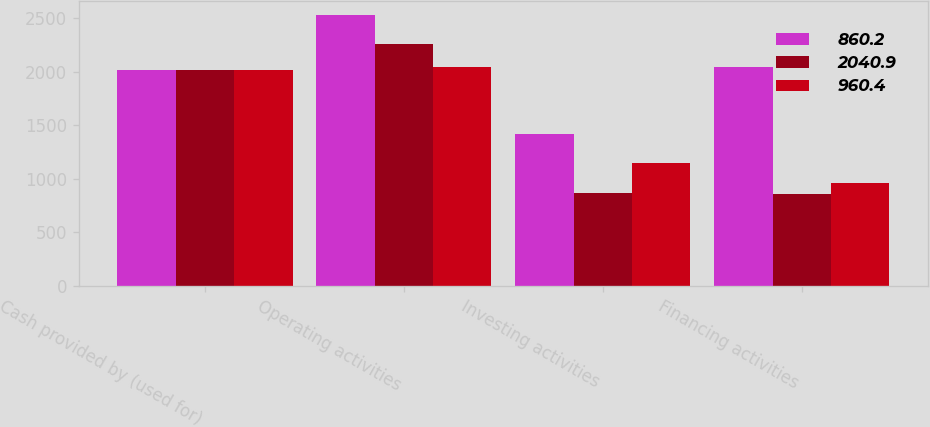Convert chart. <chart><loc_0><loc_0><loc_500><loc_500><stacked_bar_chart><ecel><fcel>Cash provided by (used for)<fcel>Operating activities<fcel>Investing activities<fcel>Financing activities<nl><fcel>860.2<fcel>2017<fcel>2534.1<fcel>1417.7<fcel>2040.9<nl><fcel>2040.9<fcel>2016<fcel>2258.8<fcel>864.8<fcel>860.2<nl><fcel>960.4<fcel>2015<fcel>2047<fcel>1146.7<fcel>960.4<nl></chart> 